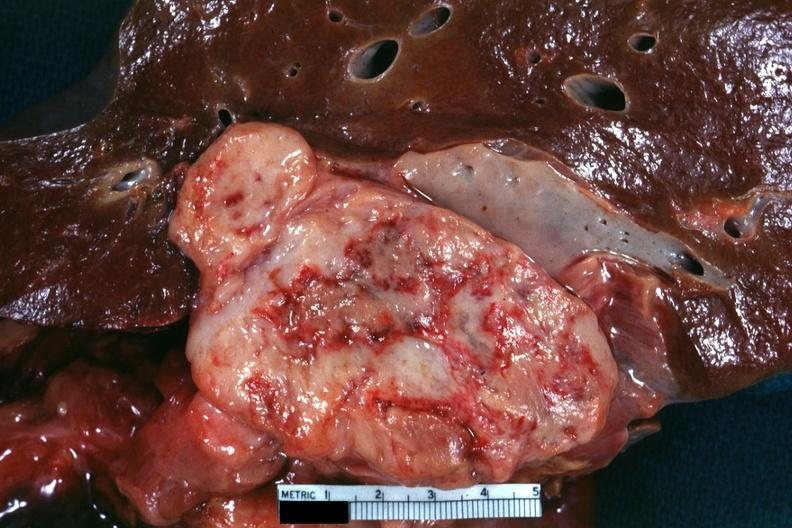s leiomyosarcoma present?
Answer the question using a single word or phrase. Yes 